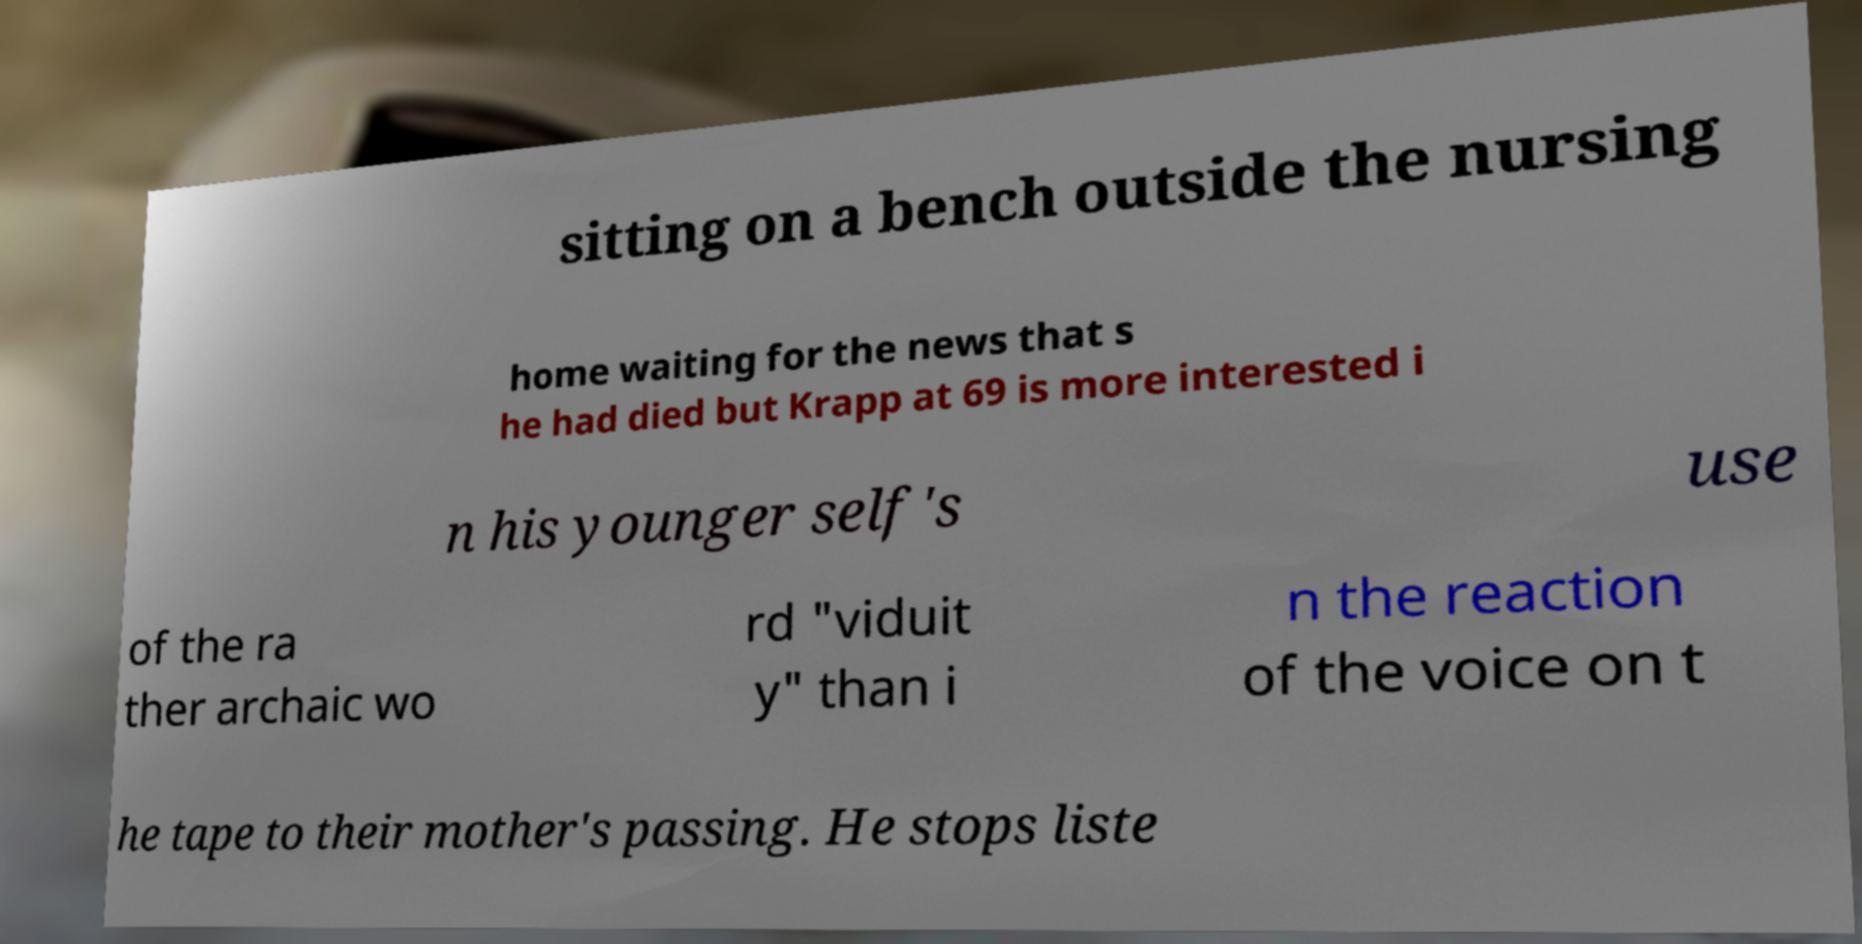There's text embedded in this image that I need extracted. Can you transcribe it verbatim? sitting on a bench outside the nursing home waiting for the news that s he had died but Krapp at 69 is more interested i n his younger self's use of the ra ther archaic wo rd "viduit y" than i n the reaction of the voice on t he tape to their mother's passing. He stops liste 